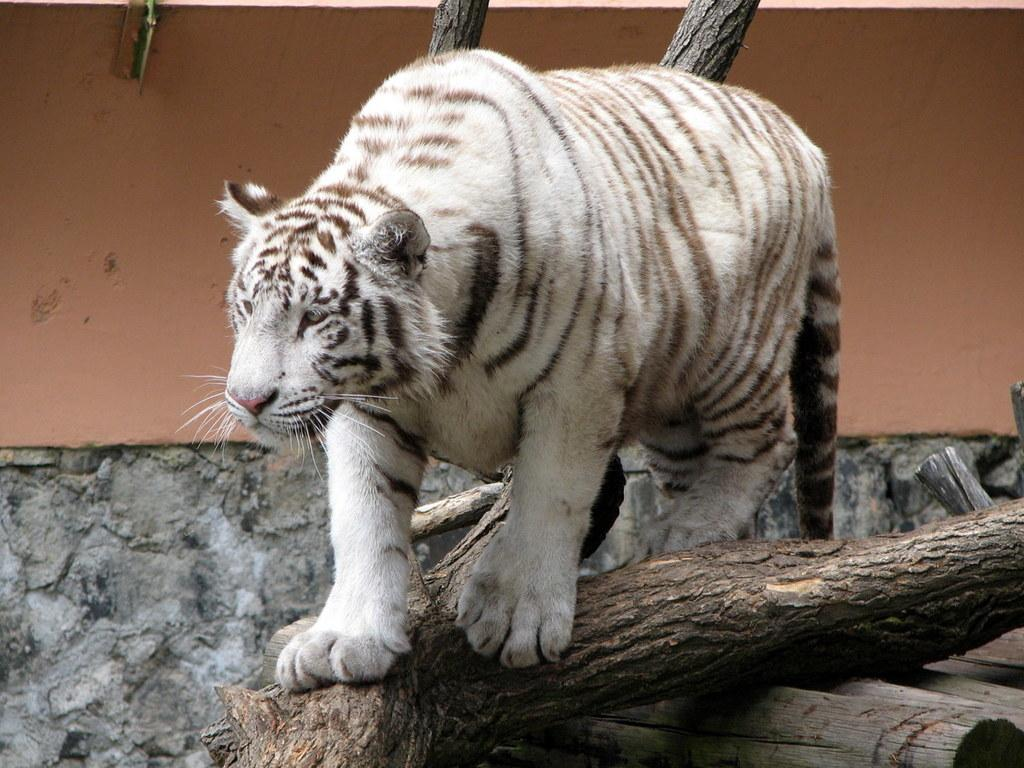What is the main subject of the image? There is an animal on a tree trunk in the image. Can you describe the setting of the image? There is a wall visible in the background of the image. Where can the lettuce be found in the image? There is no lettuce present in the image. What type of boot is the animal wearing in the image? The animal in the image is not wearing any boots. 